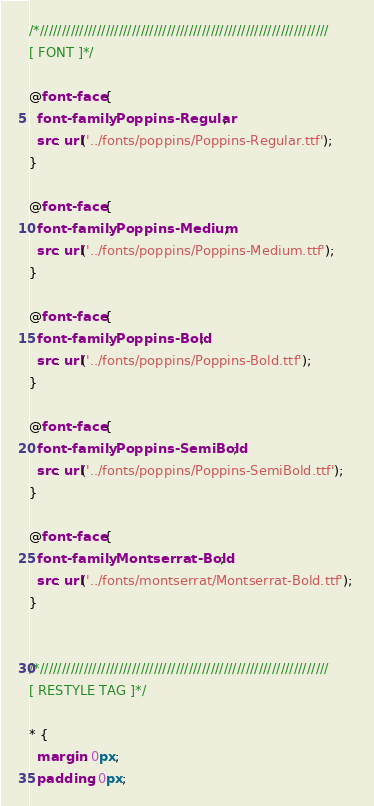Convert code to text. <code><loc_0><loc_0><loc_500><loc_500><_CSS_>



/*//////////////////////////////////////////////////////////////////
[ FONT ]*/

@font-face {
  font-family: Poppins-Regular;
  src: url('../fonts/poppins/Poppins-Regular.ttf'); 
}

@font-face {
  font-family: Poppins-Medium;
  src: url('../fonts/poppins/Poppins-Medium.ttf'); 
}

@font-face {
  font-family: Poppins-Bold;
  src: url('../fonts/poppins/Poppins-Bold.ttf'); 
}

@font-face {
  font-family: Poppins-SemiBold;
  src: url('../fonts/poppins/Poppins-SemiBold.ttf'); 
}

@font-face {
  font-family: Montserrat-Bold;
  src: url('../fonts/montserrat/Montserrat-Bold.ttf'); 
}


/*//////////////////////////////////////////////////////////////////
[ RESTYLE TAG ]*/

* {
  margin: 0px; 
  padding: 0px; </code> 